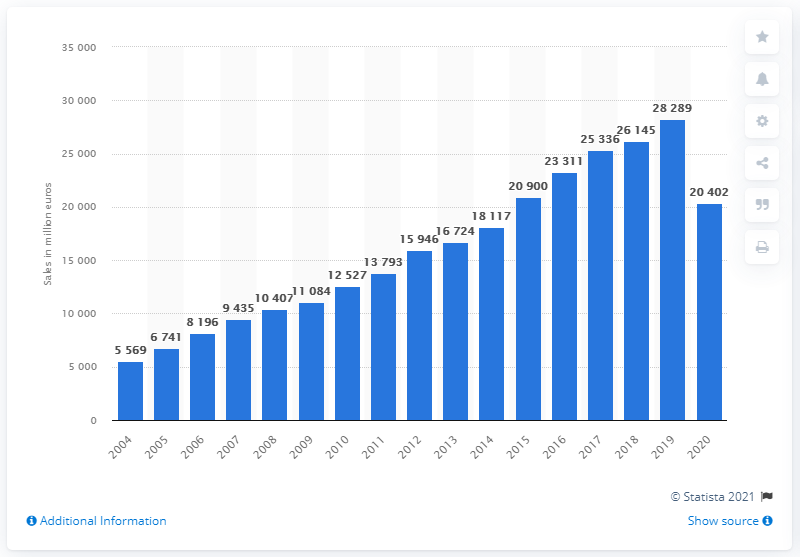Mention a couple of crucial points in this snapshot. Inditex Group generated €27.2 billion in sales in 2020. Inditex Group's sales in 2020 were significantly lower than in the previous year. 